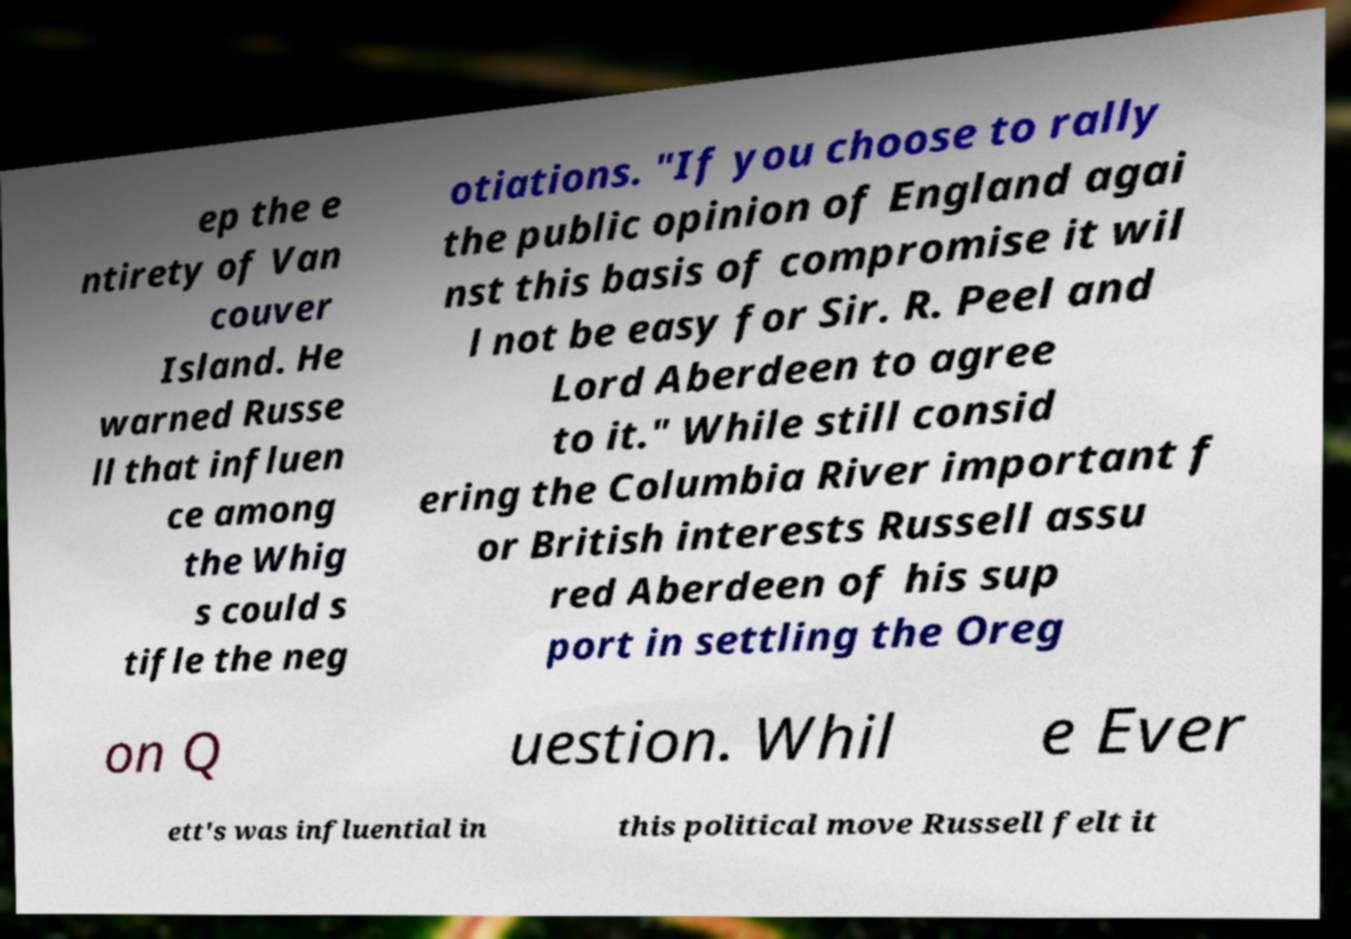Can you read and provide the text displayed in the image?This photo seems to have some interesting text. Can you extract and type it out for me? ep the e ntirety of Van couver Island. He warned Russe ll that influen ce among the Whig s could s tifle the neg otiations. "If you choose to rally the public opinion of England agai nst this basis of compromise it wil l not be easy for Sir. R. Peel and Lord Aberdeen to agree to it." While still consid ering the Columbia River important f or British interests Russell assu red Aberdeen of his sup port in settling the Oreg on Q uestion. Whil e Ever ett's was influential in this political move Russell felt it 